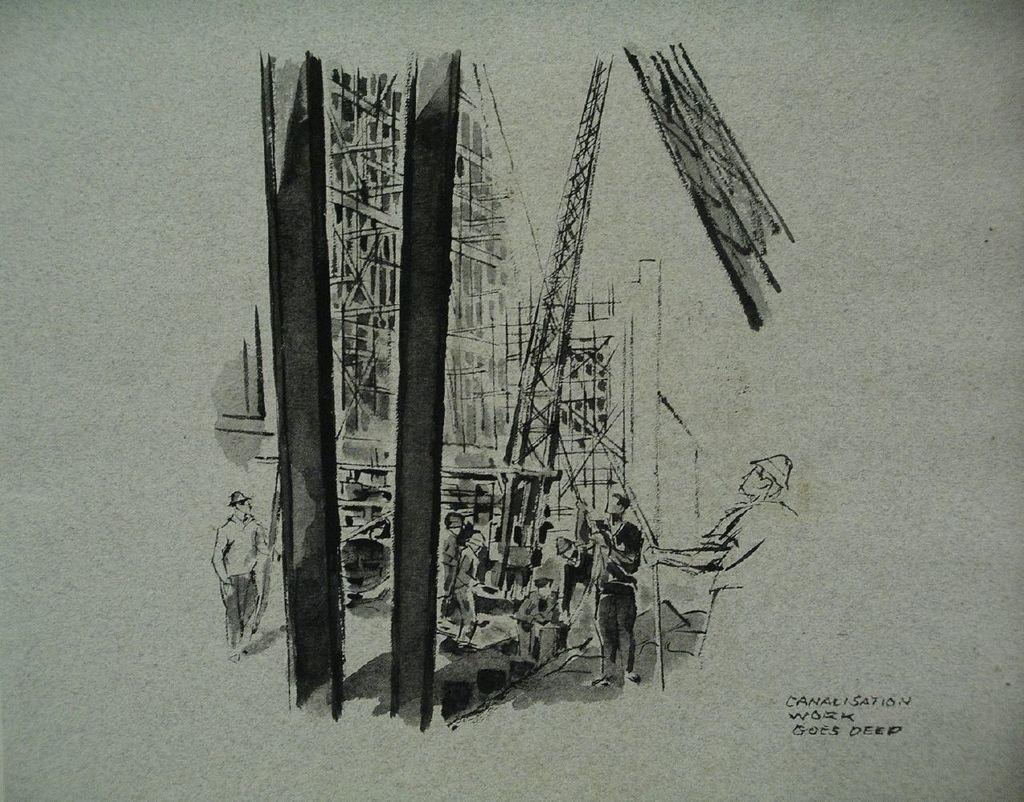What is the subject of the sketch in the image? The image is a sketch of a construction site. What can be seen at the construction site? There are buildings in the image. Are there any people present at the construction site? Yes, there are people in the image. Is there any text included in the sketch? Yes, there is text written in the bottom right corner of the image. Can you see a tiger walking around the construction site in the image? No, there is no tiger present in the image. What rule is being enforced by the people in the image? The image does not provide any information about rules being enforced; it only shows a construction site with buildings and people. 